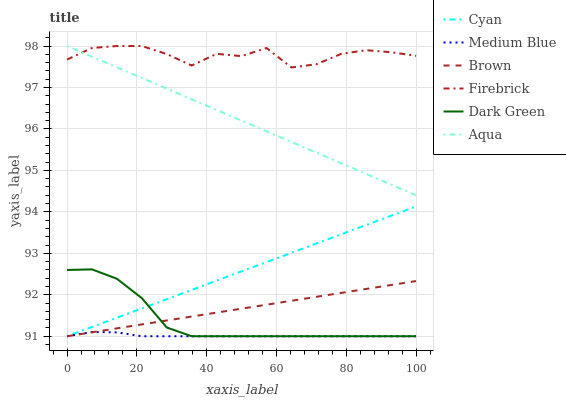Does Medium Blue have the minimum area under the curve?
Answer yes or no. Yes. Does Firebrick have the maximum area under the curve?
Answer yes or no. Yes. Does Firebrick have the minimum area under the curve?
Answer yes or no. No. Does Medium Blue have the maximum area under the curve?
Answer yes or no. No. Is Aqua the smoothest?
Answer yes or no. Yes. Is Firebrick the roughest?
Answer yes or no. Yes. Is Medium Blue the smoothest?
Answer yes or no. No. Is Medium Blue the roughest?
Answer yes or no. No. Does Brown have the lowest value?
Answer yes or no. Yes. Does Firebrick have the lowest value?
Answer yes or no. No. Does Aqua have the highest value?
Answer yes or no. Yes. Does Medium Blue have the highest value?
Answer yes or no. No. Is Brown less than Firebrick?
Answer yes or no. Yes. Is Aqua greater than Medium Blue?
Answer yes or no. Yes. Does Cyan intersect Brown?
Answer yes or no. Yes. Is Cyan less than Brown?
Answer yes or no. No. Is Cyan greater than Brown?
Answer yes or no. No. Does Brown intersect Firebrick?
Answer yes or no. No. 